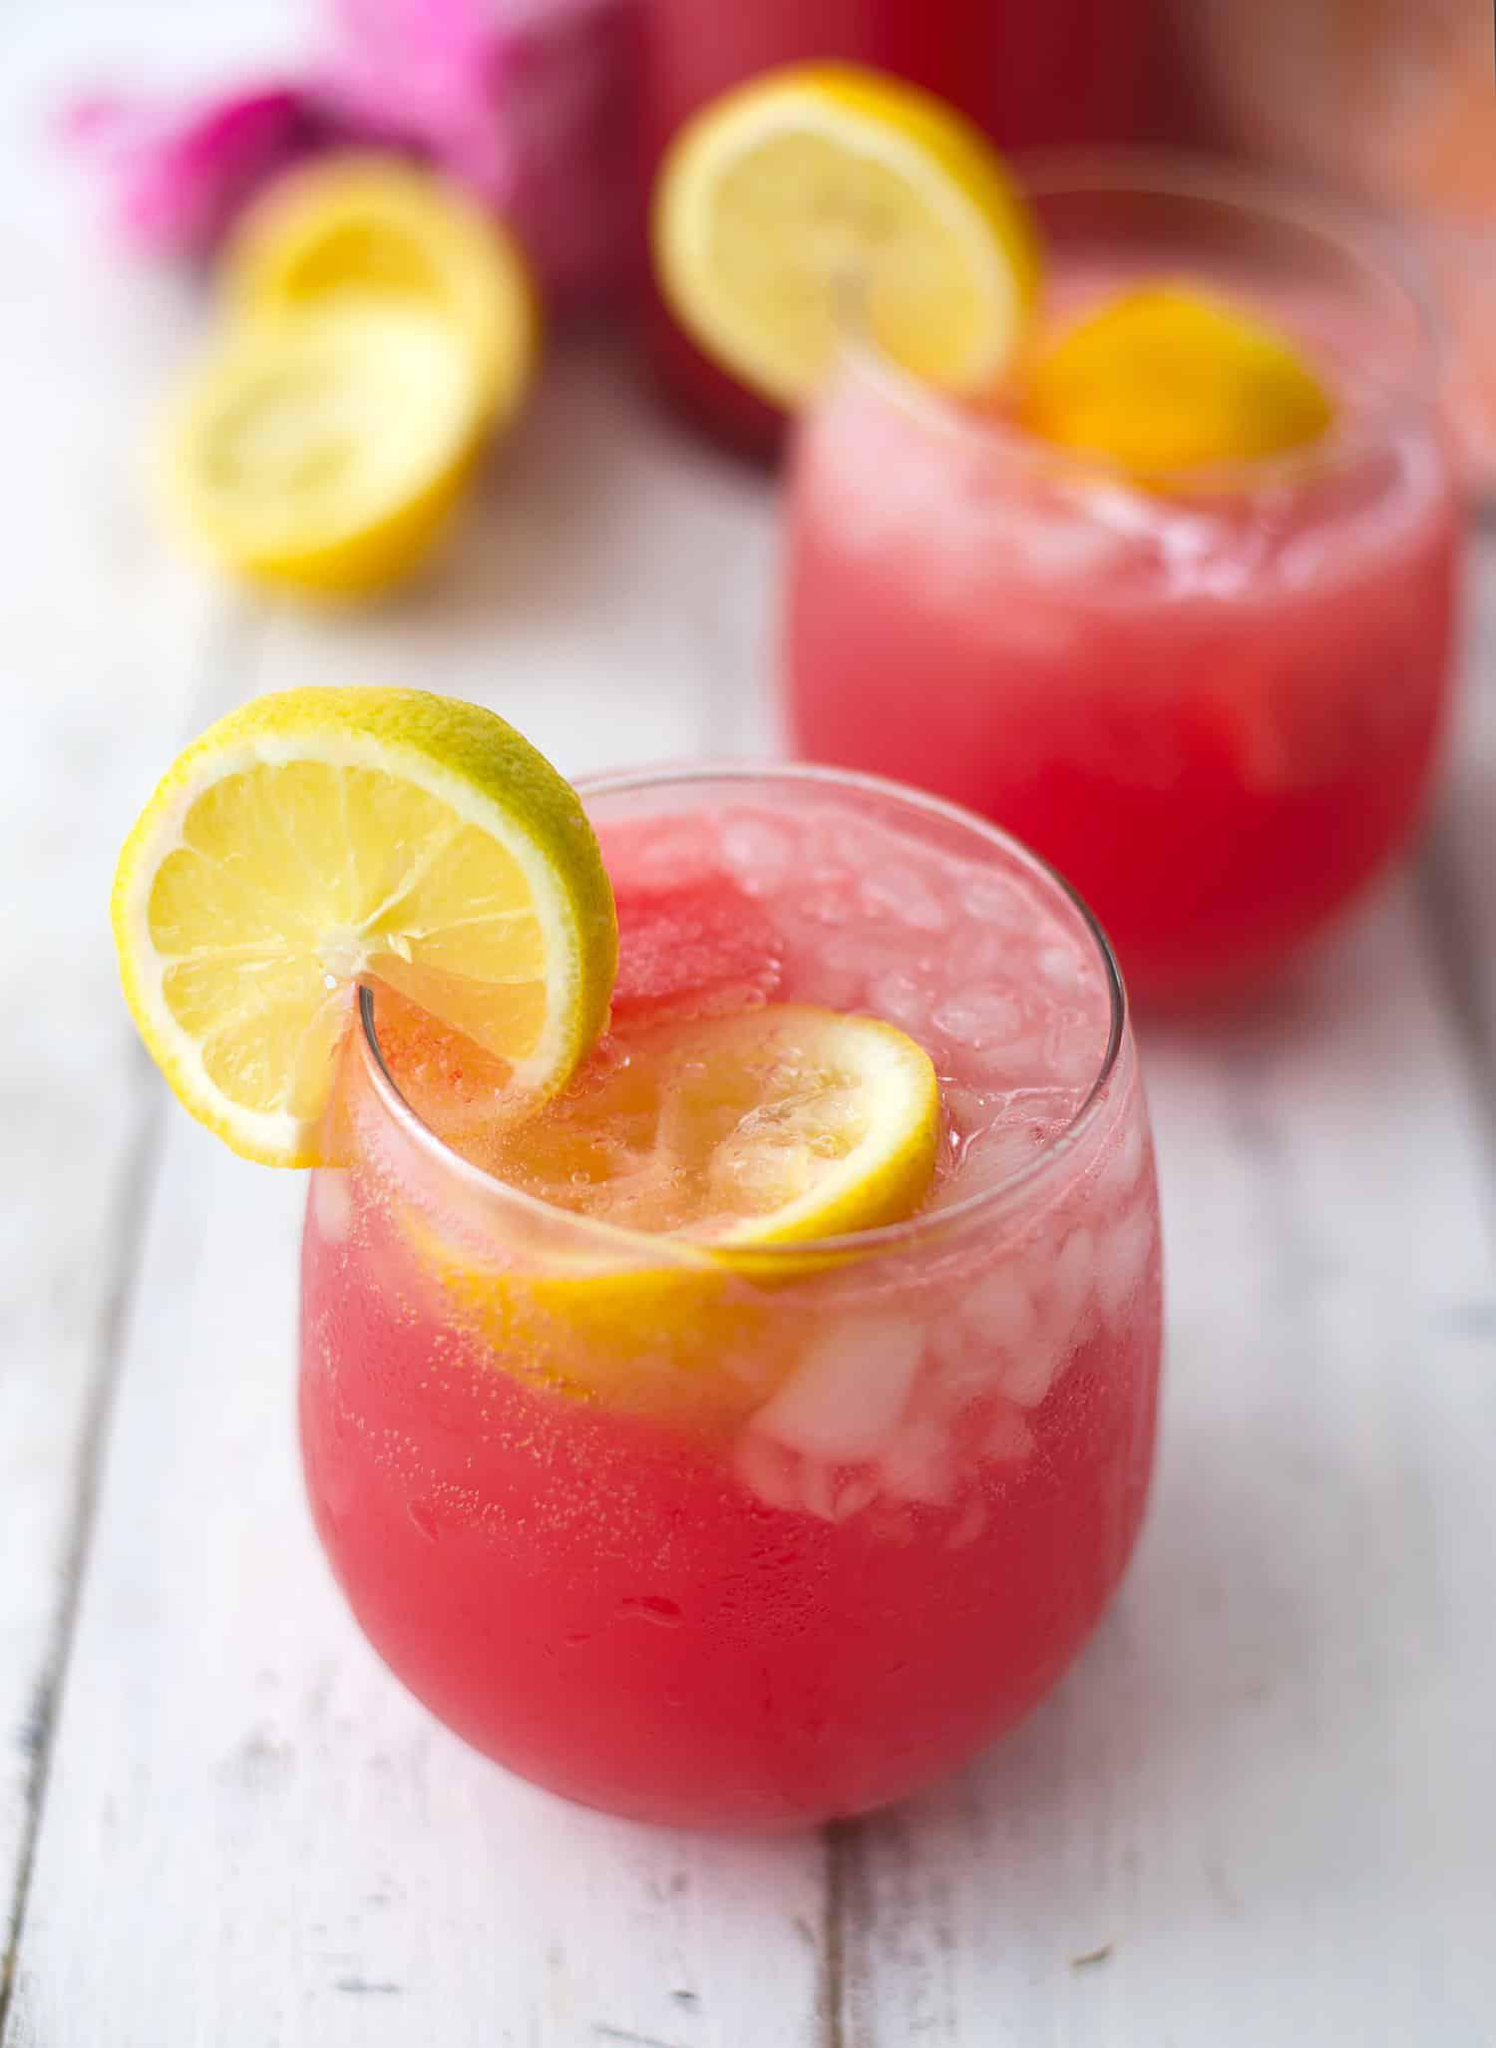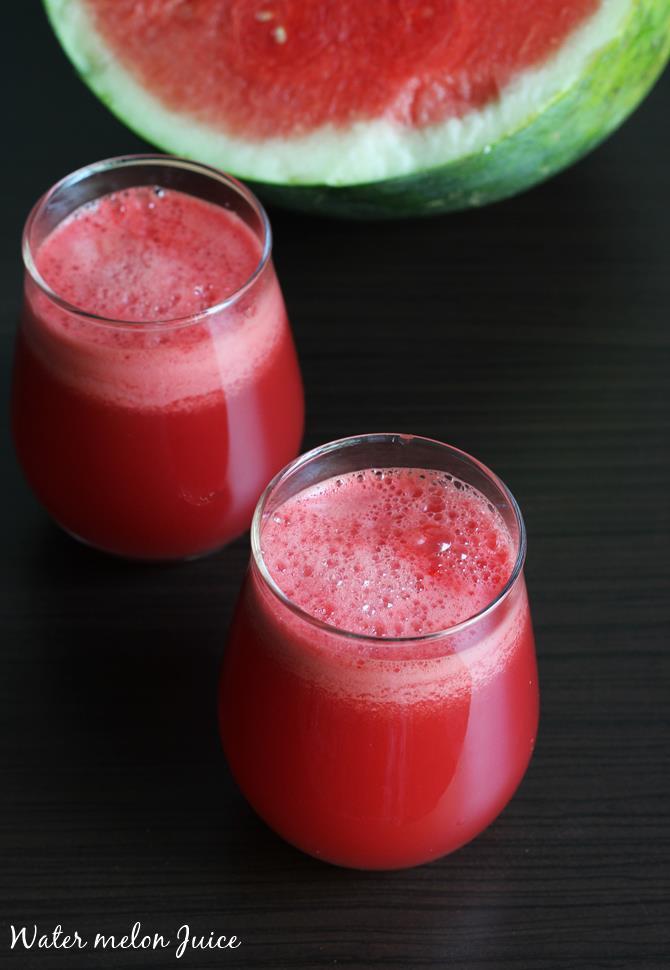The first image is the image on the left, the second image is the image on the right. Analyze the images presented: Is the assertion "Left and right images show the same number of prepared drinks in serving cups." valid? Answer yes or no. Yes. The first image is the image on the left, the second image is the image on the right. Analyze the images presented: Is the assertion "There is more than one slice of lemon in the image on the left" valid? Answer yes or no. Yes. 